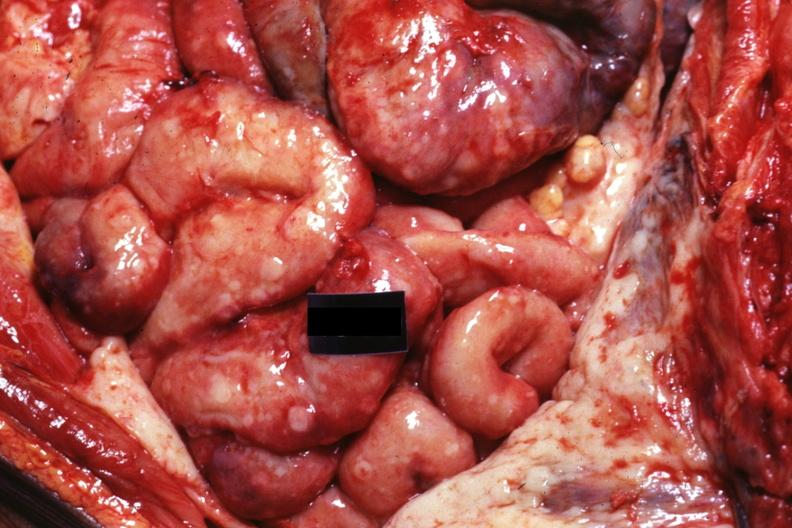s carcinomatosis present?
Answer the question using a single word or phrase. Yes 